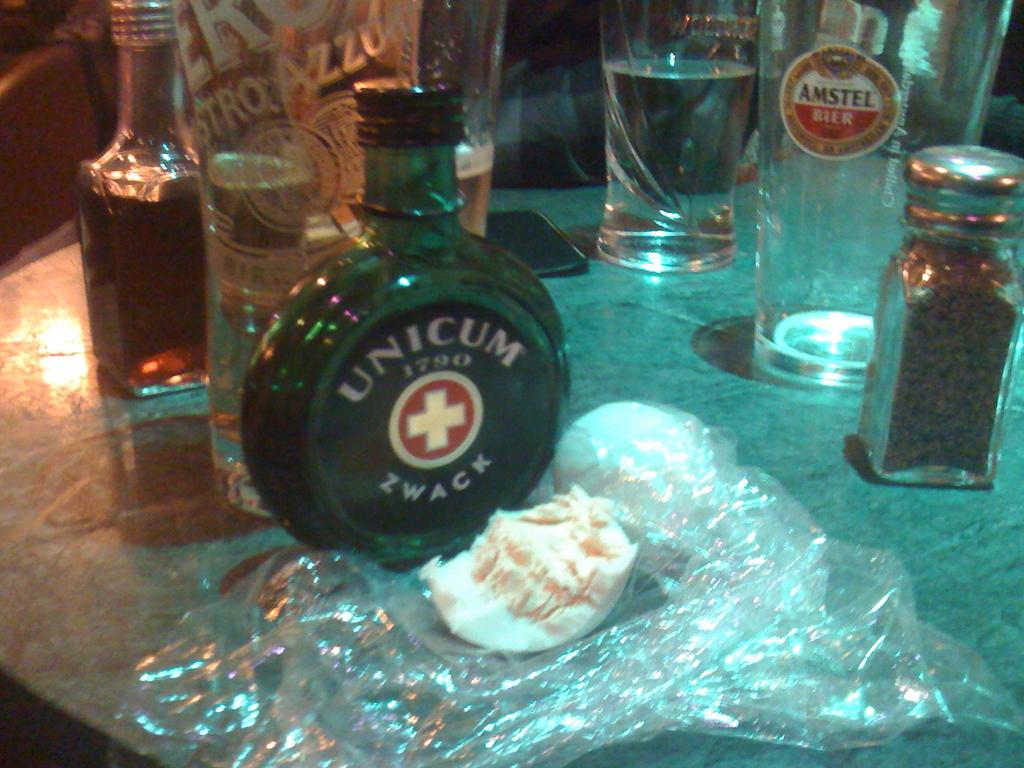What year is the unicum zwack?
Provide a succinct answer. 1790. 